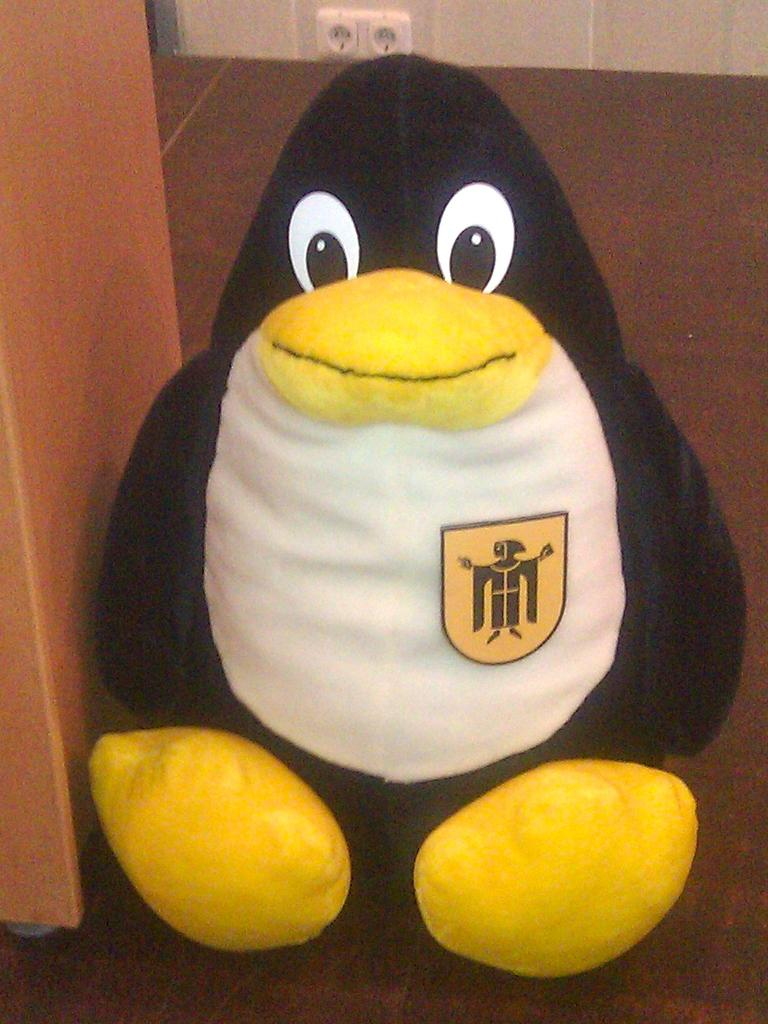What is the main object in the image? There is a toy in the image. Where is the toy located? The toy is on a surface. What other object is near the toy? There is a wooden object beside the toy. What can be seen on the wall in the image? Power sockets are visible on the wall at the top of the image. How does the kitten fold the toy in the image? There is no kitten present in the image, so it cannot fold the toy. 